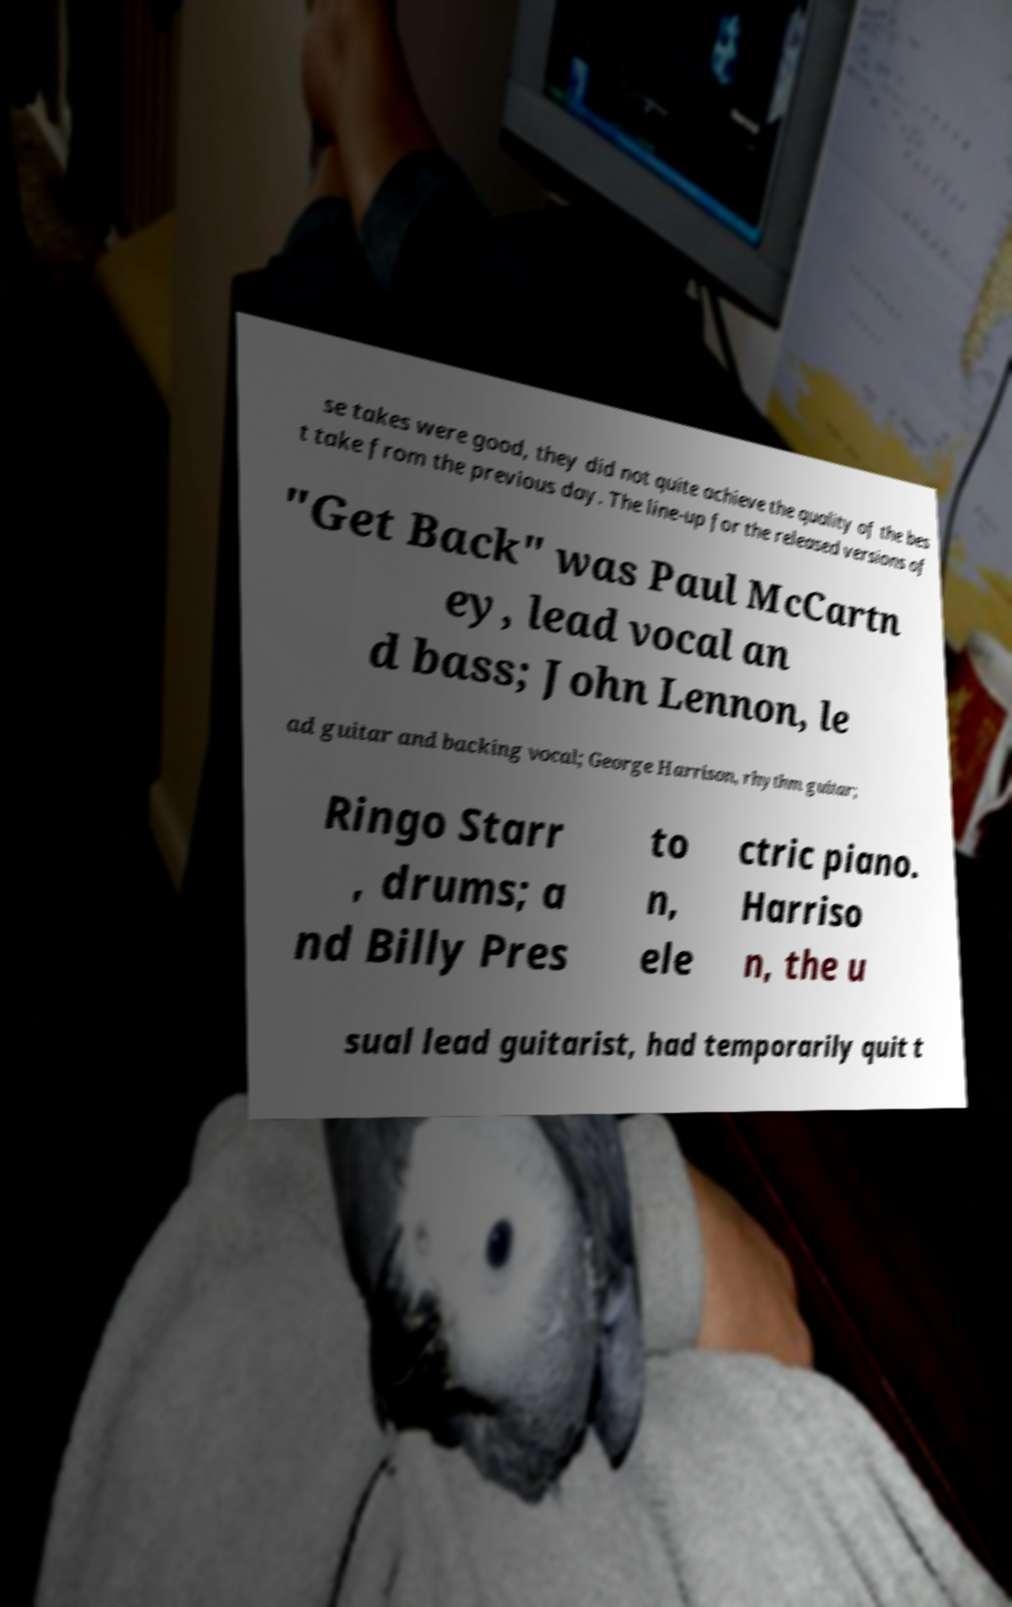What messages or text are displayed in this image? I need them in a readable, typed format. se takes were good, they did not quite achieve the quality of the bes t take from the previous day. The line-up for the released versions of "Get Back" was Paul McCartn ey, lead vocal an d bass; John Lennon, le ad guitar and backing vocal; George Harrison, rhythm guitar; Ringo Starr , drums; a nd Billy Pres to n, ele ctric piano. Harriso n, the u sual lead guitarist, had temporarily quit t 